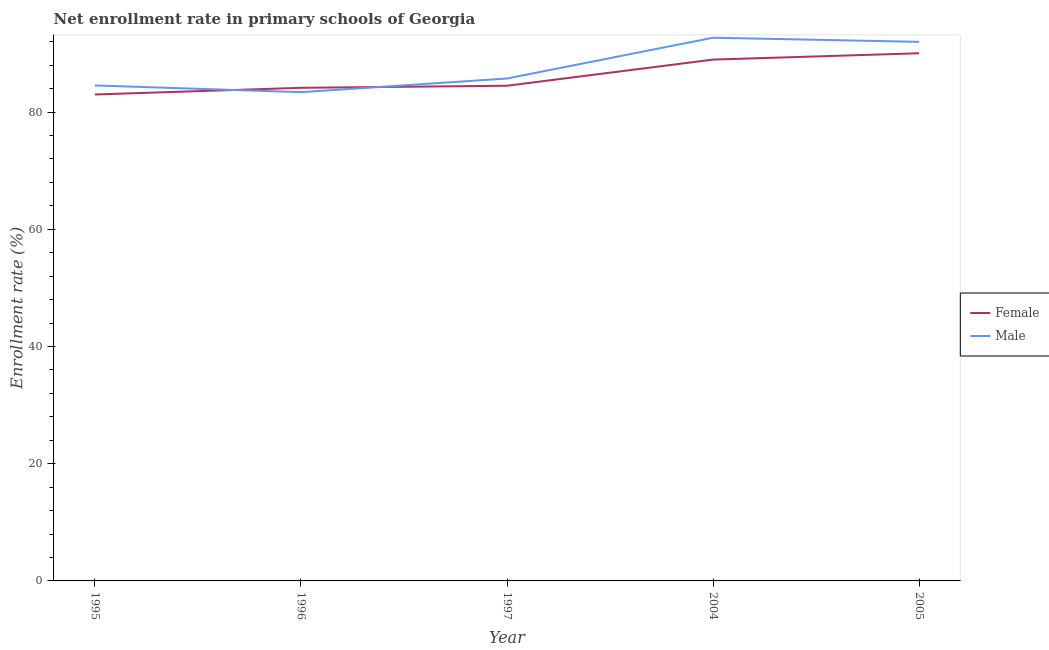How many different coloured lines are there?
Offer a terse response. 2. Is the number of lines equal to the number of legend labels?
Provide a succinct answer. Yes. What is the enrollment rate of female students in 1996?
Your answer should be compact. 84.13. Across all years, what is the maximum enrollment rate of female students?
Give a very brief answer. 90.02. Across all years, what is the minimum enrollment rate of female students?
Provide a short and direct response. 82.99. What is the total enrollment rate of female students in the graph?
Offer a terse response. 430.57. What is the difference between the enrollment rate of female students in 1997 and that in 2004?
Make the answer very short. -4.46. What is the difference between the enrollment rate of male students in 1996 and the enrollment rate of female students in 1995?
Ensure brevity in your answer.  0.39. What is the average enrollment rate of male students per year?
Give a very brief answer. 87.66. In the year 2004, what is the difference between the enrollment rate of female students and enrollment rate of male students?
Your response must be concise. -3.73. What is the ratio of the enrollment rate of male students in 1995 to that in 1996?
Your answer should be compact. 1.01. Is the enrollment rate of male students in 1995 less than that in 1997?
Provide a succinct answer. Yes. What is the difference between the highest and the second highest enrollment rate of female students?
Make the answer very short. 1.08. What is the difference between the highest and the lowest enrollment rate of female students?
Your answer should be very brief. 7.03. In how many years, is the enrollment rate of female students greater than the average enrollment rate of female students taken over all years?
Your response must be concise. 2. Is the enrollment rate of male students strictly greater than the enrollment rate of female students over the years?
Your answer should be very brief. No. Is the enrollment rate of female students strictly less than the enrollment rate of male students over the years?
Make the answer very short. No. Are the values on the major ticks of Y-axis written in scientific E-notation?
Your response must be concise. No. Does the graph contain grids?
Ensure brevity in your answer.  No. How many legend labels are there?
Ensure brevity in your answer.  2. What is the title of the graph?
Keep it short and to the point. Net enrollment rate in primary schools of Georgia. Does "Current US$" appear as one of the legend labels in the graph?
Offer a very short reply. No. What is the label or title of the Y-axis?
Your response must be concise. Enrollment rate (%). What is the Enrollment rate (%) in Female in 1995?
Ensure brevity in your answer.  82.99. What is the Enrollment rate (%) in Male in 1995?
Your answer should be compact. 84.54. What is the Enrollment rate (%) of Female in 1996?
Offer a terse response. 84.13. What is the Enrollment rate (%) of Male in 1996?
Give a very brief answer. 83.38. What is the Enrollment rate (%) of Female in 1997?
Make the answer very short. 84.48. What is the Enrollment rate (%) of Male in 1997?
Your answer should be compact. 85.72. What is the Enrollment rate (%) in Female in 2004?
Your answer should be compact. 88.94. What is the Enrollment rate (%) in Male in 2004?
Give a very brief answer. 92.68. What is the Enrollment rate (%) in Female in 2005?
Keep it short and to the point. 90.02. What is the Enrollment rate (%) of Male in 2005?
Offer a terse response. 91.97. Across all years, what is the maximum Enrollment rate (%) of Female?
Ensure brevity in your answer.  90.02. Across all years, what is the maximum Enrollment rate (%) in Male?
Offer a terse response. 92.68. Across all years, what is the minimum Enrollment rate (%) of Female?
Your answer should be very brief. 82.99. Across all years, what is the minimum Enrollment rate (%) in Male?
Your response must be concise. 83.38. What is the total Enrollment rate (%) of Female in the graph?
Your answer should be very brief. 430.57. What is the total Enrollment rate (%) of Male in the graph?
Keep it short and to the point. 438.29. What is the difference between the Enrollment rate (%) of Female in 1995 and that in 1996?
Your answer should be compact. -1.14. What is the difference between the Enrollment rate (%) of Male in 1995 and that in 1996?
Offer a terse response. 1.15. What is the difference between the Enrollment rate (%) in Female in 1995 and that in 1997?
Make the answer very short. -1.49. What is the difference between the Enrollment rate (%) of Male in 1995 and that in 1997?
Offer a very short reply. -1.18. What is the difference between the Enrollment rate (%) in Female in 1995 and that in 2004?
Make the answer very short. -5.95. What is the difference between the Enrollment rate (%) in Male in 1995 and that in 2004?
Ensure brevity in your answer.  -8.14. What is the difference between the Enrollment rate (%) of Female in 1995 and that in 2005?
Your answer should be compact. -7.03. What is the difference between the Enrollment rate (%) in Male in 1995 and that in 2005?
Make the answer very short. -7.44. What is the difference between the Enrollment rate (%) in Female in 1996 and that in 1997?
Ensure brevity in your answer.  -0.35. What is the difference between the Enrollment rate (%) in Male in 1996 and that in 1997?
Your answer should be very brief. -2.33. What is the difference between the Enrollment rate (%) of Female in 1996 and that in 2004?
Offer a terse response. -4.81. What is the difference between the Enrollment rate (%) of Male in 1996 and that in 2004?
Ensure brevity in your answer.  -9.29. What is the difference between the Enrollment rate (%) in Female in 1996 and that in 2005?
Offer a terse response. -5.89. What is the difference between the Enrollment rate (%) in Male in 1996 and that in 2005?
Offer a very short reply. -8.59. What is the difference between the Enrollment rate (%) in Female in 1997 and that in 2004?
Give a very brief answer. -4.46. What is the difference between the Enrollment rate (%) of Male in 1997 and that in 2004?
Give a very brief answer. -6.96. What is the difference between the Enrollment rate (%) of Female in 1997 and that in 2005?
Offer a terse response. -5.54. What is the difference between the Enrollment rate (%) in Male in 1997 and that in 2005?
Your answer should be compact. -6.25. What is the difference between the Enrollment rate (%) of Female in 2004 and that in 2005?
Your answer should be very brief. -1.08. What is the difference between the Enrollment rate (%) of Male in 2004 and that in 2005?
Provide a short and direct response. 0.7. What is the difference between the Enrollment rate (%) in Female in 1995 and the Enrollment rate (%) in Male in 1996?
Make the answer very short. -0.39. What is the difference between the Enrollment rate (%) of Female in 1995 and the Enrollment rate (%) of Male in 1997?
Offer a terse response. -2.73. What is the difference between the Enrollment rate (%) in Female in 1995 and the Enrollment rate (%) in Male in 2004?
Give a very brief answer. -9.69. What is the difference between the Enrollment rate (%) in Female in 1995 and the Enrollment rate (%) in Male in 2005?
Keep it short and to the point. -8.98. What is the difference between the Enrollment rate (%) in Female in 1996 and the Enrollment rate (%) in Male in 1997?
Give a very brief answer. -1.59. What is the difference between the Enrollment rate (%) of Female in 1996 and the Enrollment rate (%) of Male in 2004?
Provide a succinct answer. -8.55. What is the difference between the Enrollment rate (%) in Female in 1996 and the Enrollment rate (%) in Male in 2005?
Your response must be concise. -7.84. What is the difference between the Enrollment rate (%) of Female in 1997 and the Enrollment rate (%) of Male in 2004?
Provide a succinct answer. -8.19. What is the difference between the Enrollment rate (%) in Female in 1997 and the Enrollment rate (%) in Male in 2005?
Offer a very short reply. -7.49. What is the difference between the Enrollment rate (%) in Female in 2004 and the Enrollment rate (%) in Male in 2005?
Give a very brief answer. -3.03. What is the average Enrollment rate (%) in Female per year?
Provide a short and direct response. 86.11. What is the average Enrollment rate (%) in Male per year?
Ensure brevity in your answer.  87.66. In the year 1995, what is the difference between the Enrollment rate (%) in Female and Enrollment rate (%) in Male?
Keep it short and to the point. -1.55. In the year 1996, what is the difference between the Enrollment rate (%) of Female and Enrollment rate (%) of Male?
Offer a very short reply. 0.74. In the year 1997, what is the difference between the Enrollment rate (%) in Female and Enrollment rate (%) in Male?
Ensure brevity in your answer.  -1.23. In the year 2004, what is the difference between the Enrollment rate (%) of Female and Enrollment rate (%) of Male?
Your answer should be compact. -3.73. In the year 2005, what is the difference between the Enrollment rate (%) in Female and Enrollment rate (%) in Male?
Your answer should be very brief. -1.95. What is the ratio of the Enrollment rate (%) in Female in 1995 to that in 1996?
Your answer should be compact. 0.99. What is the ratio of the Enrollment rate (%) in Male in 1995 to that in 1996?
Make the answer very short. 1.01. What is the ratio of the Enrollment rate (%) of Female in 1995 to that in 1997?
Your answer should be very brief. 0.98. What is the ratio of the Enrollment rate (%) of Male in 1995 to that in 1997?
Your answer should be very brief. 0.99. What is the ratio of the Enrollment rate (%) of Female in 1995 to that in 2004?
Make the answer very short. 0.93. What is the ratio of the Enrollment rate (%) of Male in 1995 to that in 2004?
Your response must be concise. 0.91. What is the ratio of the Enrollment rate (%) in Female in 1995 to that in 2005?
Offer a very short reply. 0.92. What is the ratio of the Enrollment rate (%) in Male in 1995 to that in 2005?
Offer a very short reply. 0.92. What is the ratio of the Enrollment rate (%) of Male in 1996 to that in 1997?
Ensure brevity in your answer.  0.97. What is the ratio of the Enrollment rate (%) in Female in 1996 to that in 2004?
Offer a very short reply. 0.95. What is the ratio of the Enrollment rate (%) of Male in 1996 to that in 2004?
Offer a terse response. 0.9. What is the ratio of the Enrollment rate (%) of Female in 1996 to that in 2005?
Make the answer very short. 0.93. What is the ratio of the Enrollment rate (%) of Male in 1996 to that in 2005?
Provide a short and direct response. 0.91. What is the ratio of the Enrollment rate (%) in Female in 1997 to that in 2004?
Provide a succinct answer. 0.95. What is the ratio of the Enrollment rate (%) of Male in 1997 to that in 2004?
Your answer should be very brief. 0.92. What is the ratio of the Enrollment rate (%) in Female in 1997 to that in 2005?
Offer a terse response. 0.94. What is the ratio of the Enrollment rate (%) in Male in 1997 to that in 2005?
Offer a very short reply. 0.93. What is the ratio of the Enrollment rate (%) in Female in 2004 to that in 2005?
Offer a very short reply. 0.99. What is the ratio of the Enrollment rate (%) of Male in 2004 to that in 2005?
Your answer should be compact. 1.01. What is the difference between the highest and the second highest Enrollment rate (%) of Female?
Your answer should be very brief. 1.08. What is the difference between the highest and the second highest Enrollment rate (%) in Male?
Offer a terse response. 0.7. What is the difference between the highest and the lowest Enrollment rate (%) in Female?
Your response must be concise. 7.03. What is the difference between the highest and the lowest Enrollment rate (%) of Male?
Your response must be concise. 9.29. 